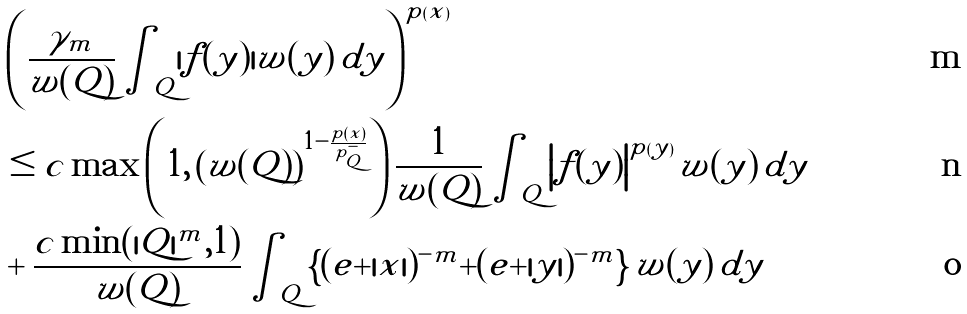Convert formula to latex. <formula><loc_0><loc_0><loc_500><loc_500>& \left ( \frac { \gamma _ { m } } { w ( Q ) } \int _ { Q } | f ( y ) | w ( y ) \, d y \right ) ^ { p ( x ) } \\ & \leq c \max \left ( 1 , \left ( w ( Q ) \right ) ^ { 1 - \frac { p \left ( x \right ) } { p _ { Q } ^ { - } } } \right ) \frac { 1 } { w ( Q ) } \int _ { Q } \left | f ( y ) \right | ^ { p ( y ) } w ( y ) \, d y \\ & + \frac { c \min ( | Q | ^ { m } , 1 ) } { w ( Q ) } \int _ { Q } \left \{ ( e + | x | ) ^ { - m } + ( e + | y | ) ^ { - m } \right \} w ( y ) \, d y</formula> 